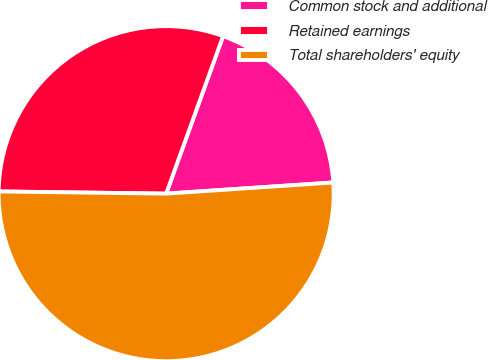Convert chart. <chart><loc_0><loc_0><loc_500><loc_500><pie_chart><fcel>Common stock and additional<fcel>Retained earnings<fcel>Total shareholders' equity<nl><fcel>18.42%<fcel>30.31%<fcel>51.27%<nl></chart> 